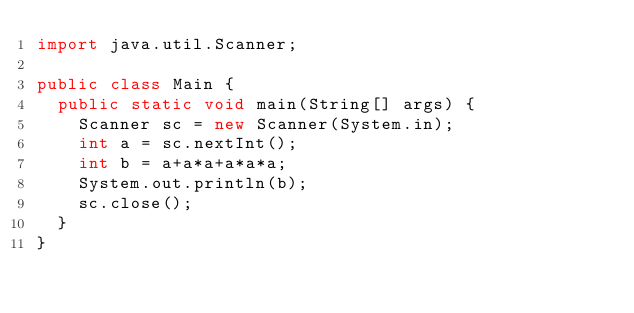<code> <loc_0><loc_0><loc_500><loc_500><_Java_>import java.util.Scanner;

public class Main {
	public static void main(String[] args) {
		Scanner sc = new Scanner(System.in);
		int a = sc.nextInt();
		int b = a+a*a+a*a*a;
		System.out.println(b);
		sc.close();
	}
}
</code> 